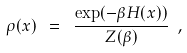<formula> <loc_0><loc_0><loc_500><loc_500>\rho ( x ) \ = \ \frac { \exp ( - \beta H ( x ) ) } { Z ( \beta ) } \ ,</formula> 